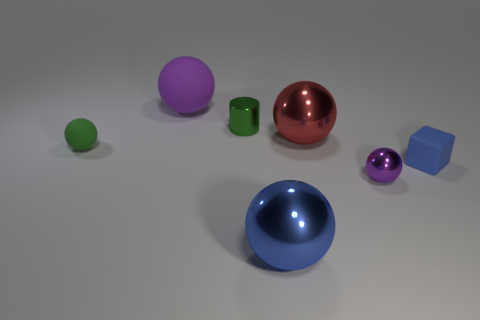Subtract all big purple rubber spheres. How many spheres are left? 4 Subtract all red balls. How many balls are left? 4 Subtract all brown spheres. Subtract all red cylinders. How many spheres are left? 5 Add 3 green matte things. How many objects exist? 10 Subtract all cylinders. How many objects are left? 6 Add 1 big things. How many big things are left? 4 Add 3 small yellow shiny cylinders. How many small yellow shiny cylinders exist? 3 Subtract 1 blue blocks. How many objects are left? 6 Subtract all blue blocks. Subtract all small blue blocks. How many objects are left? 5 